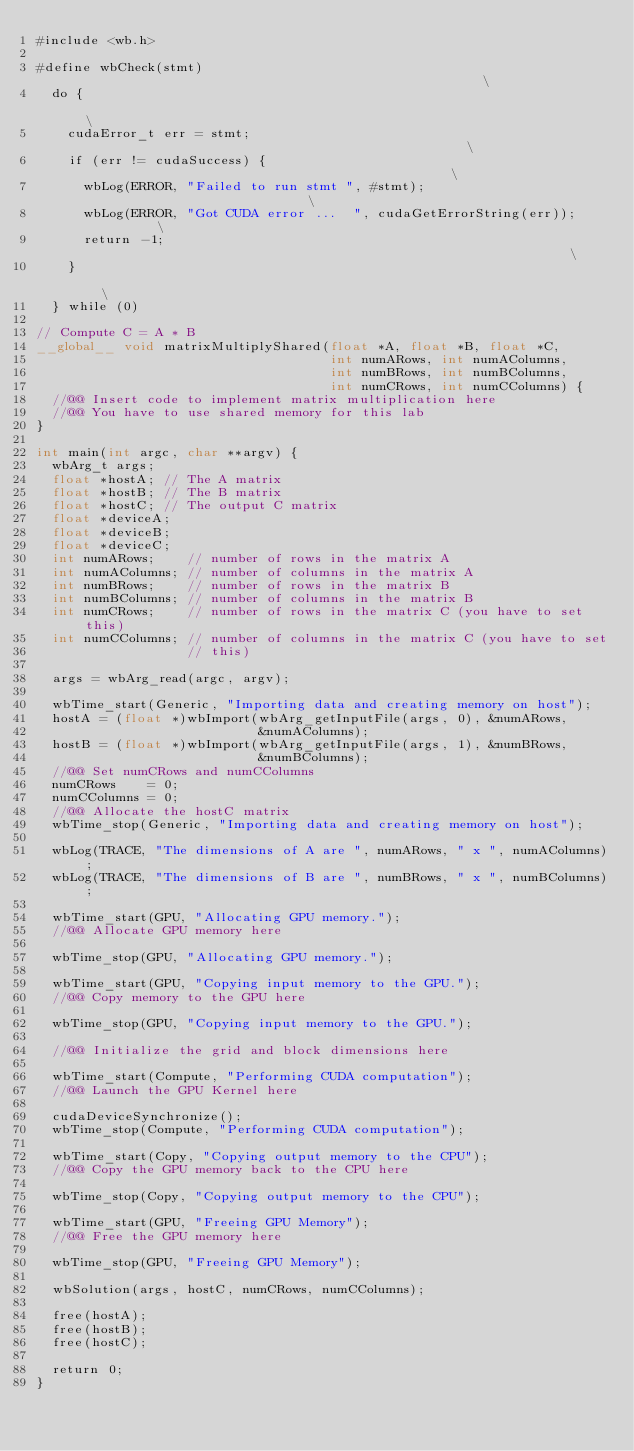<code> <loc_0><loc_0><loc_500><loc_500><_Cuda_>#include <wb.h>

#define wbCheck(stmt)                                                     \
  do {                                                                    \
    cudaError_t err = stmt;                                               \
    if (err != cudaSuccess) {                                             \
      wbLog(ERROR, "Failed to run stmt ", #stmt);                         \
      wbLog(ERROR, "Got CUDA error ...  ", cudaGetErrorString(err));      \
      return -1;                                                          \
    }                                                                     \
  } while (0)

// Compute C = A * B
__global__ void matrixMultiplyShared(float *A, float *B, float *C,
                                     int numARows, int numAColumns,
                                     int numBRows, int numBColumns,
                                     int numCRows, int numCColumns) {
  //@@ Insert code to implement matrix multiplication here
  //@@ You have to use shared memory for this lab
}

int main(int argc, char **argv) {
  wbArg_t args;
  float *hostA; // The A matrix
  float *hostB; // The B matrix
  float *hostC; // The output C matrix
  float *deviceA;
  float *deviceB;
  float *deviceC;
  int numARows;    // number of rows in the matrix A
  int numAColumns; // number of columns in the matrix A
  int numBRows;    // number of rows in the matrix B
  int numBColumns; // number of columns in the matrix B
  int numCRows;    // number of rows in the matrix C (you have to set this)
  int numCColumns; // number of columns in the matrix C (you have to set
                   // this)

  args = wbArg_read(argc, argv);

  wbTime_start(Generic, "Importing data and creating memory on host");
  hostA = (float *)wbImport(wbArg_getInputFile(args, 0), &numARows,
                            &numAColumns);
  hostB = (float *)wbImport(wbArg_getInputFile(args, 1), &numBRows,
                            &numBColumns);
  //@@ Set numCRows and numCColumns
  numCRows    = 0;
  numCColumns = 0;
  //@@ Allocate the hostC matrix
  wbTime_stop(Generic, "Importing data and creating memory on host");

  wbLog(TRACE, "The dimensions of A are ", numARows, " x ", numAColumns);
  wbLog(TRACE, "The dimensions of B are ", numBRows, " x ", numBColumns);

  wbTime_start(GPU, "Allocating GPU memory.");
  //@@ Allocate GPU memory here

  wbTime_stop(GPU, "Allocating GPU memory.");

  wbTime_start(GPU, "Copying input memory to the GPU.");
  //@@ Copy memory to the GPU here

  wbTime_stop(GPU, "Copying input memory to the GPU.");

  //@@ Initialize the grid and block dimensions here

  wbTime_start(Compute, "Performing CUDA computation");
  //@@ Launch the GPU Kernel here

  cudaDeviceSynchronize();
  wbTime_stop(Compute, "Performing CUDA computation");

  wbTime_start(Copy, "Copying output memory to the CPU");
  //@@ Copy the GPU memory back to the CPU here

  wbTime_stop(Copy, "Copying output memory to the CPU");

  wbTime_start(GPU, "Freeing GPU Memory");
  //@@ Free the GPU memory here

  wbTime_stop(GPU, "Freeing GPU Memory");

  wbSolution(args, hostC, numCRows, numCColumns);

  free(hostA);
  free(hostB);
  free(hostC);

  return 0;
}
</code> 